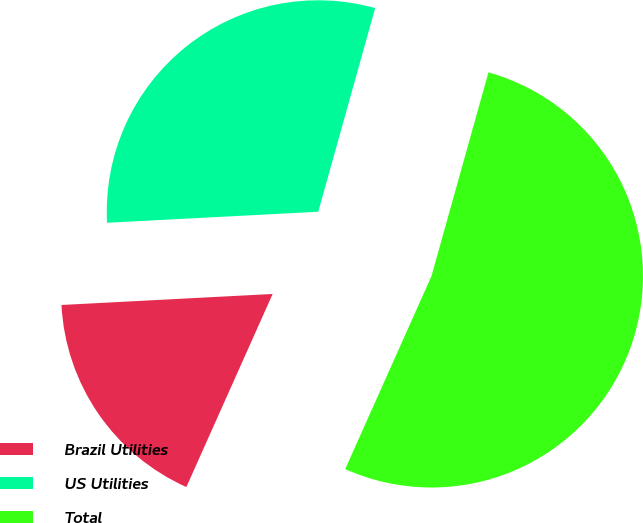Convert chart to OTSL. <chart><loc_0><loc_0><loc_500><loc_500><pie_chart><fcel>Brazil Utilities<fcel>US Utilities<fcel>Total<nl><fcel>17.48%<fcel>30.17%<fcel>52.35%<nl></chart> 